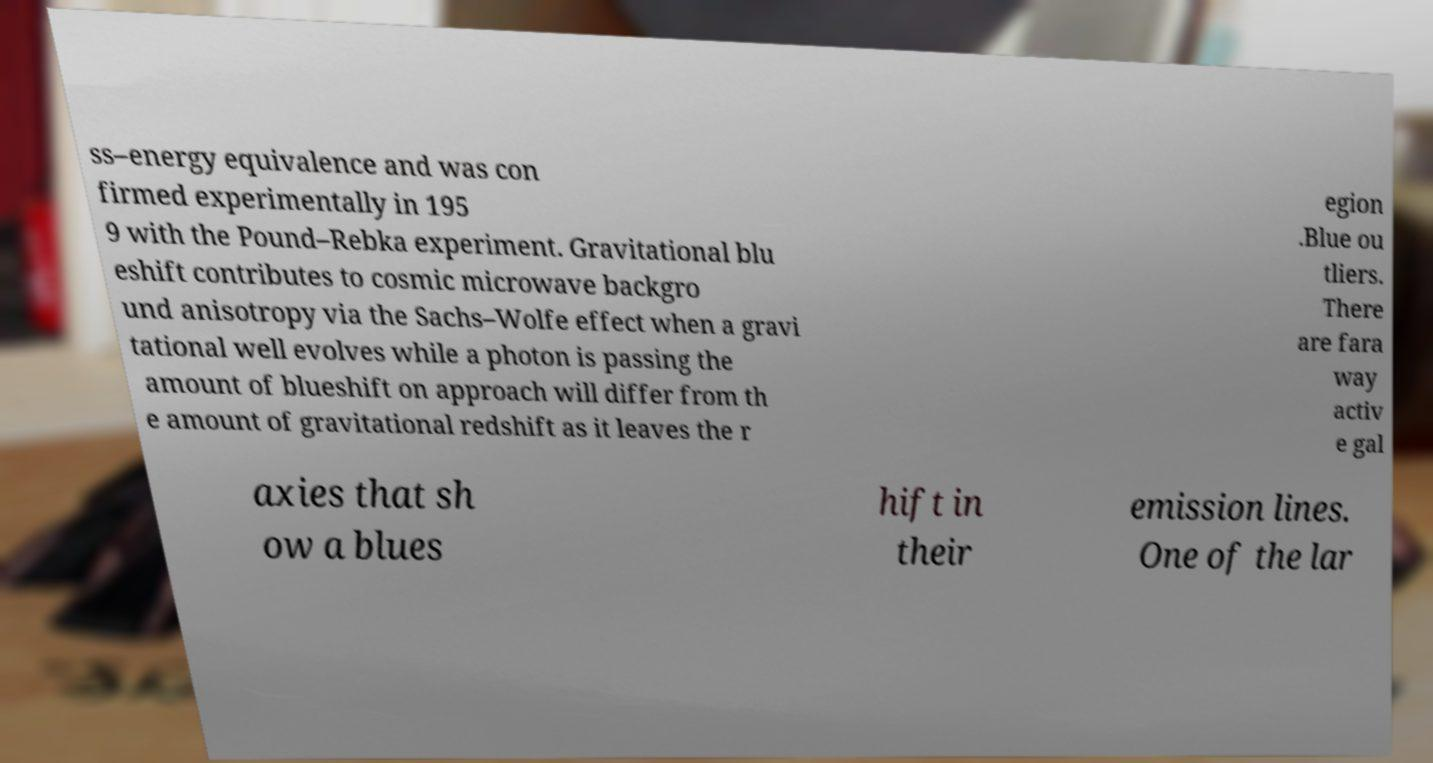There's text embedded in this image that I need extracted. Can you transcribe it verbatim? ss–energy equivalence and was con firmed experimentally in 195 9 with the Pound–Rebka experiment. Gravitational blu eshift contributes to cosmic microwave backgro und anisotropy via the Sachs–Wolfe effect when a gravi tational well evolves while a photon is passing the amount of blueshift on approach will differ from th e amount of gravitational redshift as it leaves the r egion .Blue ou tliers. There are fara way activ e gal axies that sh ow a blues hift in their emission lines. One of the lar 